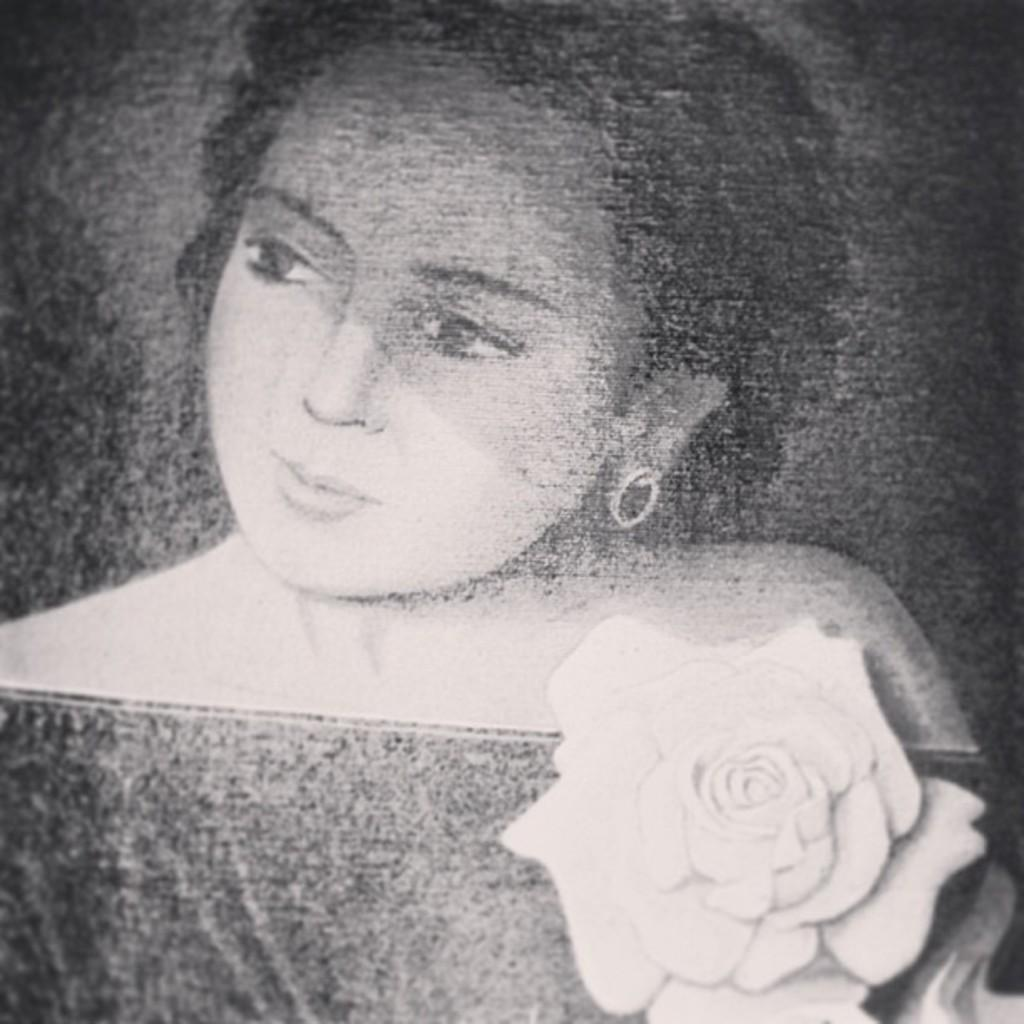What is the color scheme of the image? The image is black and white. Who is present in the image? There is a woman in the image. What can be seen on the shoulder of the woman? There is a rose flower on the shoulder of the woman. What type of band is playing in the background of the image? There is no band present in the image; it is a black and white image of a woman with a rose flower on her shoulder. 